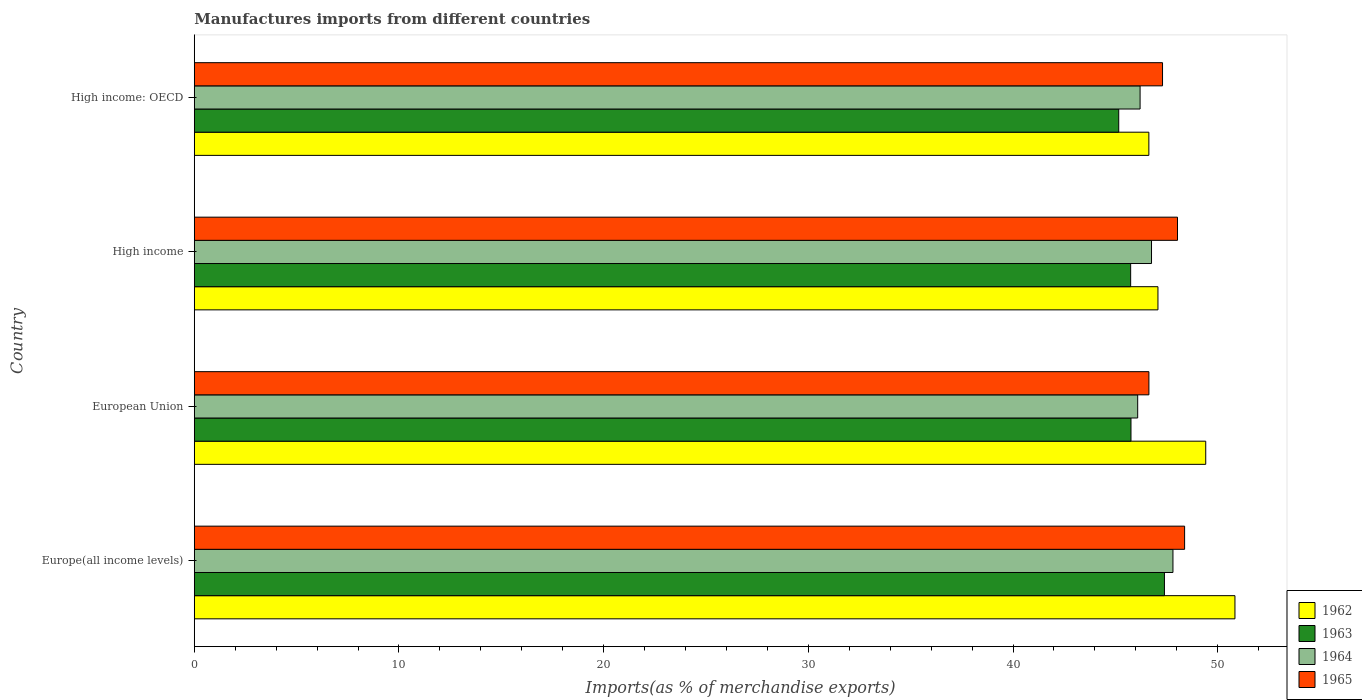How many groups of bars are there?
Keep it short and to the point. 4. Are the number of bars per tick equal to the number of legend labels?
Your answer should be very brief. Yes. How many bars are there on the 1st tick from the top?
Keep it short and to the point. 4. What is the label of the 1st group of bars from the top?
Keep it short and to the point. High income: OECD. What is the percentage of imports to different countries in 1964 in High income: OECD?
Your answer should be compact. 46.21. Across all countries, what is the maximum percentage of imports to different countries in 1964?
Your answer should be compact. 47.81. Across all countries, what is the minimum percentage of imports to different countries in 1965?
Ensure brevity in your answer.  46.64. In which country was the percentage of imports to different countries in 1963 maximum?
Ensure brevity in your answer.  Europe(all income levels). In which country was the percentage of imports to different countries in 1964 minimum?
Offer a very short reply. European Union. What is the total percentage of imports to different countries in 1963 in the graph?
Offer a very short reply. 184.07. What is the difference between the percentage of imports to different countries in 1962 in European Union and that in High income: OECD?
Offer a terse response. 2.78. What is the difference between the percentage of imports to different countries in 1962 in High income: OECD and the percentage of imports to different countries in 1963 in European Union?
Your answer should be very brief. 0.87. What is the average percentage of imports to different countries in 1964 per country?
Offer a very short reply. 46.72. What is the difference between the percentage of imports to different countries in 1964 and percentage of imports to different countries in 1963 in High income: OECD?
Provide a succinct answer. 1.04. What is the ratio of the percentage of imports to different countries in 1962 in Europe(all income levels) to that in European Union?
Your response must be concise. 1.03. Is the percentage of imports to different countries in 1965 in Europe(all income levels) less than that in High income: OECD?
Ensure brevity in your answer.  No. Is the difference between the percentage of imports to different countries in 1964 in Europe(all income levels) and High income: OECD greater than the difference between the percentage of imports to different countries in 1963 in Europe(all income levels) and High income: OECD?
Offer a very short reply. No. What is the difference between the highest and the second highest percentage of imports to different countries in 1964?
Make the answer very short. 1.05. What is the difference between the highest and the lowest percentage of imports to different countries in 1964?
Provide a short and direct response. 1.72. In how many countries, is the percentage of imports to different countries in 1963 greater than the average percentage of imports to different countries in 1963 taken over all countries?
Your answer should be compact. 1. Is it the case that in every country, the sum of the percentage of imports to different countries in 1964 and percentage of imports to different countries in 1962 is greater than the sum of percentage of imports to different countries in 1963 and percentage of imports to different countries in 1965?
Keep it short and to the point. Yes. Is it the case that in every country, the sum of the percentage of imports to different countries in 1962 and percentage of imports to different countries in 1965 is greater than the percentage of imports to different countries in 1963?
Offer a terse response. Yes. Are all the bars in the graph horizontal?
Give a very brief answer. Yes. What is the difference between two consecutive major ticks on the X-axis?
Give a very brief answer. 10. Are the values on the major ticks of X-axis written in scientific E-notation?
Your answer should be very brief. No. Does the graph contain grids?
Give a very brief answer. No. Where does the legend appear in the graph?
Make the answer very short. Bottom right. How many legend labels are there?
Give a very brief answer. 4. What is the title of the graph?
Offer a terse response. Manufactures imports from different countries. Does "1972" appear as one of the legend labels in the graph?
Make the answer very short. No. What is the label or title of the X-axis?
Offer a very short reply. Imports(as % of merchandise exports). What is the label or title of the Y-axis?
Provide a short and direct response. Country. What is the Imports(as % of merchandise exports) of 1962 in Europe(all income levels)?
Ensure brevity in your answer.  50.84. What is the Imports(as % of merchandise exports) in 1963 in Europe(all income levels)?
Provide a short and direct response. 47.4. What is the Imports(as % of merchandise exports) of 1964 in Europe(all income levels)?
Provide a short and direct response. 47.81. What is the Imports(as % of merchandise exports) in 1965 in Europe(all income levels)?
Offer a terse response. 48.38. What is the Imports(as % of merchandise exports) of 1962 in European Union?
Ensure brevity in your answer.  49.41. What is the Imports(as % of merchandise exports) of 1963 in European Union?
Ensure brevity in your answer.  45.76. What is the Imports(as % of merchandise exports) of 1964 in European Union?
Your answer should be compact. 46.09. What is the Imports(as % of merchandise exports) of 1965 in European Union?
Make the answer very short. 46.64. What is the Imports(as % of merchandise exports) of 1962 in High income?
Ensure brevity in your answer.  47.08. What is the Imports(as % of merchandise exports) of 1963 in High income?
Give a very brief answer. 45.75. What is the Imports(as % of merchandise exports) of 1964 in High income?
Ensure brevity in your answer.  46.77. What is the Imports(as % of merchandise exports) in 1965 in High income?
Offer a terse response. 48.04. What is the Imports(as % of merchandise exports) of 1962 in High income: OECD?
Offer a terse response. 46.64. What is the Imports(as % of merchandise exports) of 1963 in High income: OECD?
Ensure brevity in your answer.  45.16. What is the Imports(as % of merchandise exports) in 1964 in High income: OECD?
Your answer should be very brief. 46.21. What is the Imports(as % of merchandise exports) of 1965 in High income: OECD?
Keep it short and to the point. 47.3. Across all countries, what is the maximum Imports(as % of merchandise exports) of 1962?
Give a very brief answer. 50.84. Across all countries, what is the maximum Imports(as % of merchandise exports) of 1963?
Your answer should be compact. 47.4. Across all countries, what is the maximum Imports(as % of merchandise exports) in 1964?
Your response must be concise. 47.81. Across all countries, what is the maximum Imports(as % of merchandise exports) of 1965?
Offer a terse response. 48.38. Across all countries, what is the minimum Imports(as % of merchandise exports) in 1962?
Give a very brief answer. 46.64. Across all countries, what is the minimum Imports(as % of merchandise exports) in 1963?
Offer a terse response. 45.16. Across all countries, what is the minimum Imports(as % of merchandise exports) of 1964?
Your answer should be very brief. 46.09. Across all countries, what is the minimum Imports(as % of merchandise exports) in 1965?
Provide a succinct answer. 46.64. What is the total Imports(as % of merchandise exports) of 1962 in the graph?
Keep it short and to the point. 193.97. What is the total Imports(as % of merchandise exports) in 1963 in the graph?
Provide a succinct answer. 184.07. What is the total Imports(as % of merchandise exports) in 1964 in the graph?
Make the answer very short. 186.88. What is the total Imports(as % of merchandise exports) in 1965 in the graph?
Provide a succinct answer. 190.36. What is the difference between the Imports(as % of merchandise exports) of 1962 in Europe(all income levels) and that in European Union?
Your answer should be very brief. 1.43. What is the difference between the Imports(as % of merchandise exports) in 1963 in Europe(all income levels) and that in European Union?
Your response must be concise. 1.63. What is the difference between the Imports(as % of merchandise exports) in 1964 in Europe(all income levels) and that in European Union?
Your answer should be compact. 1.72. What is the difference between the Imports(as % of merchandise exports) in 1965 in Europe(all income levels) and that in European Union?
Your answer should be compact. 1.74. What is the difference between the Imports(as % of merchandise exports) of 1962 in Europe(all income levels) and that in High income?
Your answer should be very brief. 3.76. What is the difference between the Imports(as % of merchandise exports) of 1963 in Europe(all income levels) and that in High income?
Make the answer very short. 1.65. What is the difference between the Imports(as % of merchandise exports) of 1964 in Europe(all income levels) and that in High income?
Make the answer very short. 1.05. What is the difference between the Imports(as % of merchandise exports) in 1965 in Europe(all income levels) and that in High income?
Give a very brief answer. 0.35. What is the difference between the Imports(as % of merchandise exports) of 1962 in Europe(all income levels) and that in High income: OECD?
Offer a very short reply. 4.21. What is the difference between the Imports(as % of merchandise exports) of 1963 in Europe(all income levels) and that in High income: OECD?
Offer a terse response. 2.23. What is the difference between the Imports(as % of merchandise exports) in 1964 in Europe(all income levels) and that in High income: OECD?
Give a very brief answer. 1.61. What is the difference between the Imports(as % of merchandise exports) in 1965 in Europe(all income levels) and that in High income: OECD?
Provide a short and direct response. 1.08. What is the difference between the Imports(as % of merchandise exports) in 1962 in European Union and that in High income?
Offer a terse response. 2.33. What is the difference between the Imports(as % of merchandise exports) of 1963 in European Union and that in High income?
Your response must be concise. 0.02. What is the difference between the Imports(as % of merchandise exports) of 1964 in European Union and that in High income?
Your answer should be compact. -0.68. What is the difference between the Imports(as % of merchandise exports) of 1965 in European Union and that in High income?
Offer a very short reply. -1.4. What is the difference between the Imports(as % of merchandise exports) in 1962 in European Union and that in High income: OECD?
Your answer should be very brief. 2.78. What is the difference between the Imports(as % of merchandise exports) in 1963 in European Union and that in High income: OECD?
Ensure brevity in your answer.  0.6. What is the difference between the Imports(as % of merchandise exports) in 1964 in European Union and that in High income: OECD?
Offer a terse response. -0.12. What is the difference between the Imports(as % of merchandise exports) of 1965 in European Union and that in High income: OECD?
Provide a short and direct response. -0.67. What is the difference between the Imports(as % of merchandise exports) in 1962 in High income and that in High income: OECD?
Your response must be concise. 0.44. What is the difference between the Imports(as % of merchandise exports) in 1963 in High income and that in High income: OECD?
Give a very brief answer. 0.58. What is the difference between the Imports(as % of merchandise exports) of 1964 in High income and that in High income: OECD?
Provide a succinct answer. 0.56. What is the difference between the Imports(as % of merchandise exports) in 1965 in High income and that in High income: OECD?
Your response must be concise. 0.73. What is the difference between the Imports(as % of merchandise exports) of 1962 in Europe(all income levels) and the Imports(as % of merchandise exports) of 1963 in European Union?
Your response must be concise. 5.08. What is the difference between the Imports(as % of merchandise exports) of 1962 in Europe(all income levels) and the Imports(as % of merchandise exports) of 1964 in European Union?
Your response must be concise. 4.75. What is the difference between the Imports(as % of merchandise exports) in 1962 in Europe(all income levels) and the Imports(as % of merchandise exports) in 1965 in European Union?
Offer a terse response. 4.2. What is the difference between the Imports(as % of merchandise exports) in 1963 in Europe(all income levels) and the Imports(as % of merchandise exports) in 1964 in European Union?
Offer a very short reply. 1.31. What is the difference between the Imports(as % of merchandise exports) in 1963 in Europe(all income levels) and the Imports(as % of merchandise exports) in 1965 in European Union?
Give a very brief answer. 0.76. What is the difference between the Imports(as % of merchandise exports) of 1964 in Europe(all income levels) and the Imports(as % of merchandise exports) of 1965 in European Union?
Ensure brevity in your answer.  1.18. What is the difference between the Imports(as % of merchandise exports) of 1962 in Europe(all income levels) and the Imports(as % of merchandise exports) of 1963 in High income?
Make the answer very short. 5.1. What is the difference between the Imports(as % of merchandise exports) of 1962 in Europe(all income levels) and the Imports(as % of merchandise exports) of 1964 in High income?
Make the answer very short. 4.08. What is the difference between the Imports(as % of merchandise exports) in 1962 in Europe(all income levels) and the Imports(as % of merchandise exports) in 1965 in High income?
Offer a terse response. 2.81. What is the difference between the Imports(as % of merchandise exports) in 1963 in Europe(all income levels) and the Imports(as % of merchandise exports) in 1964 in High income?
Offer a terse response. 0.63. What is the difference between the Imports(as % of merchandise exports) in 1963 in Europe(all income levels) and the Imports(as % of merchandise exports) in 1965 in High income?
Your response must be concise. -0.64. What is the difference between the Imports(as % of merchandise exports) of 1964 in Europe(all income levels) and the Imports(as % of merchandise exports) of 1965 in High income?
Provide a short and direct response. -0.22. What is the difference between the Imports(as % of merchandise exports) of 1962 in Europe(all income levels) and the Imports(as % of merchandise exports) of 1963 in High income: OECD?
Offer a terse response. 5.68. What is the difference between the Imports(as % of merchandise exports) of 1962 in Europe(all income levels) and the Imports(as % of merchandise exports) of 1964 in High income: OECD?
Your answer should be very brief. 4.63. What is the difference between the Imports(as % of merchandise exports) of 1962 in Europe(all income levels) and the Imports(as % of merchandise exports) of 1965 in High income: OECD?
Keep it short and to the point. 3.54. What is the difference between the Imports(as % of merchandise exports) in 1963 in Europe(all income levels) and the Imports(as % of merchandise exports) in 1964 in High income: OECD?
Your answer should be very brief. 1.19. What is the difference between the Imports(as % of merchandise exports) in 1963 in Europe(all income levels) and the Imports(as % of merchandise exports) in 1965 in High income: OECD?
Ensure brevity in your answer.  0.09. What is the difference between the Imports(as % of merchandise exports) of 1964 in Europe(all income levels) and the Imports(as % of merchandise exports) of 1965 in High income: OECD?
Make the answer very short. 0.51. What is the difference between the Imports(as % of merchandise exports) of 1962 in European Union and the Imports(as % of merchandise exports) of 1963 in High income?
Your response must be concise. 3.67. What is the difference between the Imports(as % of merchandise exports) in 1962 in European Union and the Imports(as % of merchandise exports) in 1964 in High income?
Provide a succinct answer. 2.65. What is the difference between the Imports(as % of merchandise exports) of 1962 in European Union and the Imports(as % of merchandise exports) of 1965 in High income?
Keep it short and to the point. 1.38. What is the difference between the Imports(as % of merchandise exports) of 1963 in European Union and the Imports(as % of merchandise exports) of 1964 in High income?
Your answer should be compact. -1. What is the difference between the Imports(as % of merchandise exports) of 1963 in European Union and the Imports(as % of merchandise exports) of 1965 in High income?
Keep it short and to the point. -2.27. What is the difference between the Imports(as % of merchandise exports) in 1964 in European Union and the Imports(as % of merchandise exports) in 1965 in High income?
Give a very brief answer. -1.94. What is the difference between the Imports(as % of merchandise exports) of 1962 in European Union and the Imports(as % of merchandise exports) of 1963 in High income: OECD?
Offer a terse response. 4.25. What is the difference between the Imports(as % of merchandise exports) in 1962 in European Union and the Imports(as % of merchandise exports) in 1964 in High income: OECD?
Your response must be concise. 3.21. What is the difference between the Imports(as % of merchandise exports) of 1962 in European Union and the Imports(as % of merchandise exports) of 1965 in High income: OECD?
Make the answer very short. 2.11. What is the difference between the Imports(as % of merchandise exports) in 1963 in European Union and the Imports(as % of merchandise exports) in 1964 in High income: OECD?
Provide a succinct answer. -0.44. What is the difference between the Imports(as % of merchandise exports) of 1963 in European Union and the Imports(as % of merchandise exports) of 1965 in High income: OECD?
Your answer should be very brief. -1.54. What is the difference between the Imports(as % of merchandise exports) in 1964 in European Union and the Imports(as % of merchandise exports) in 1965 in High income: OECD?
Keep it short and to the point. -1.21. What is the difference between the Imports(as % of merchandise exports) of 1962 in High income and the Imports(as % of merchandise exports) of 1963 in High income: OECD?
Provide a succinct answer. 1.92. What is the difference between the Imports(as % of merchandise exports) of 1962 in High income and the Imports(as % of merchandise exports) of 1964 in High income: OECD?
Your answer should be very brief. 0.87. What is the difference between the Imports(as % of merchandise exports) of 1962 in High income and the Imports(as % of merchandise exports) of 1965 in High income: OECD?
Your answer should be very brief. -0.22. What is the difference between the Imports(as % of merchandise exports) in 1963 in High income and the Imports(as % of merchandise exports) in 1964 in High income: OECD?
Your response must be concise. -0.46. What is the difference between the Imports(as % of merchandise exports) in 1963 in High income and the Imports(as % of merchandise exports) in 1965 in High income: OECD?
Offer a terse response. -1.56. What is the difference between the Imports(as % of merchandise exports) in 1964 in High income and the Imports(as % of merchandise exports) in 1965 in High income: OECD?
Your answer should be compact. -0.54. What is the average Imports(as % of merchandise exports) in 1962 per country?
Your response must be concise. 48.49. What is the average Imports(as % of merchandise exports) of 1963 per country?
Provide a short and direct response. 46.02. What is the average Imports(as % of merchandise exports) of 1964 per country?
Ensure brevity in your answer.  46.72. What is the average Imports(as % of merchandise exports) in 1965 per country?
Make the answer very short. 47.59. What is the difference between the Imports(as % of merchandise exports) of 1962 and Imports(as % of merchandise exports) of 1963 in Europe(all income levels)?
Give a very brief answer. 3.45. What is the difference between the Imports(as % of merchandise exports) of 1962 and Imports(as % of merchandise exports) of 1964 in Europe(all income levels)?
Ensure brevity in your answer.  3.03. What is the difference between the Imports(as % of merchandise exports) in 1962 and Imports(as % of merchandise exports) in 1965 in Europe(all income levels)?
Your answer should be compact. 2.46. What is the difference between the Imports(as % of merchandise exports) in 1963 and Imports(as % of merchandise exports) in 1964 in Europe(all income levels)?
Provide a short and direct response. -0.42. What is the difference between the Imports(as % of merchandise exports) of 1963 and Imports(as % of merchandise exports) of 1965 in Europe(all income levels)?
Your answer should be very brief. -0.99. What is the difference between the Imports(as % of merchandise exports) of 1964 and Imports(as % of merchandise exports) of 1965 in Europe(all income levels)?
Your response must be concise. -0.57. What is the difference between the Imports(as % of merchandise exports) in 1962 and Imports(as % of merchandise exports) in 1963 in European Union?
Your answer should be compact. 3.65. What is the difference between the Imports(as % of merchandise exports) of 1962 and Imports(as % of merchandise exports) of 1964 in European Union?
Offer a terse response. 3.32. What is the difference between the Imports(as % of merchandise exports) in 1962 and Imports(as % of merchandise exports) in 1965 in European Union?
Your answer should be compact. 2.78. What is the difference between the Imports(as % of merchandise exports) in 1963 and Imports(as % of merchandise exports) in 1964 in European Union?
Provide a succinct answer. -0.33. What is the difference between the Imports(as % of merchandise exports) of 1963 and Imports(as % of merchandise exports) of 1965 in European Union?
Your response must be concise. -0.88. What is the difference between the Imports(as % of merchandise exports) of 1964 and Imports(as % of merchandise exports) of 1965 in European Union?
Provide a succinct answer. -0.55. What is the difference between the Imports(as % of merchandise exports) of 1962 and Imports(as % of merchandise exports) of 1963 in High income?
Give a very brief answer. 1.33. What is the difference between the Imports(as % of merchandise exports) of 1962 and Imports(as % of merchandise exports) of 1964 in High income?
Your answer should be compact. 0.31. What is the difference between the Imports(as % of merchandise exports) in 1962 and Imports(as % of merchandise exports) in 1965 in High income?
Ensure brevity in your answer.  -0.96. What is the difference between the Imports(as % of merchandise exports) in 1963 and Imports(as % of merchandise exports) in 1964 in High income?
Provide a short and direct response. -1.02. What is the difference between the Imports(as % of merchandise exports) of 1963 and Imports(as % of merchandise exports) of 1965 in High income?
Your answer should be compact. -2.29. What is the difference between the Imports(as % of merchandise exports) in 1964 and Imports(as % of merchandise exports) in 1965 in High income?
Ensure brevity in your answer.  -1.27. What is the difference between the Imports(as % of merchandise exports) in 1962 and Imports(as % of merchandise exports) in 1963 in High income: OECD?
Your answer should be very brief. 1.47. What is the difference between the Imports(as % of merchandise exports) in 1962 and Imports(as % of merchandise exports) in 1964 in High income: OECD?
Your response must be concise. 0.43. What is the difference between the Imports(as % of merchandise exports) in 1962 and Imports(as % of merchandise exports) in 1965 in High income: OECD?
Your response must be concise. -0.67. What is the difference between the Imports(as % of merchandise exports) of 1963 and Imports(as % of merchandise exports) of 1964 in High income: OECD?
Offer a terse response. -1.04. What is the difference between the Imports(as % of merchandise exports) of 1963 and Imports(as % of merchandise exports) of 1965 in High income: OECD?
Offer a very short reply. -2.14. What is the difference between the Imports(as % of merchandise exports) of 1964 and Imports(as % of merchandise exports) of 1965 in High income: OECD?
Keep it short and to the point. -1.1. What is the ratio of the Imports(as % of merchandise exports) in 1962 in Europe(all income levels) to that in European Union?
Give a very brief answer. 1.03. What is the ratio of the Imports(as % of merchandise exports) in 1963 in Europe(all income levels) to that in European Union?
Your answer should be compact. 1.04. What is the ratio of the Imports(as % of merchandise exports) in 1964 in Europe(all income levels) to that in European Union?
Make the answer very short. 1.04. What is the ratio of the Imports(as % of merchandise exports) of 1965 in Europe(all income levels) to that in European Union?
Ensure brevity in your answer.  1.04. What is the ratio of the Imports(as % of merchandise exports) of 1962 in Europe(all income levels) to that in High income?
Provide a short and direct response. 1.08. What is the ratio of the Imports(as % of merchandise exports) of 1963 in Europe(all income levels) to that in High income?
Ensure brevity in your answer.  1.04. What is the ratio of the Imports(as % of merchandise exports) in 1964 in Europe(all income levels) to that in High income?
Provide a succinct answer. 1.02. What is the ratio of the Imports(as % of merchandise exports) in 1962 in Europe(all income levels) to that in High income: OECD?
Make the answer very short. 1.09. What is the ratio of the Imports(as % of merchandise exports) in 1963 in Europe(all income levels) to that in High income: OECD?
Give a very brief answer. 1.05. What is the ratio of the Imports(as % of merchandise exports) in 1964 in Europe(all income levels) to that in High income: OECD?
Your response must be concise. 1.03. What is the ratio of the Imports(as % of merchandise exports) of 1965 in Europe(all income levels) to that in High income: OECD?
Keep it short and to the point. 1.02. What is the ratio of the Imports(as % of merchandise exports) in 1962 in European Union to that in High income?
Your answer should be very brief. 1.05. What is the ratio of the Imports(as % of merchandise exports) of 1963 in European Union to that in High income?
Your response must be concise. 1. What is the ratio of the Imports(as % of merchandise exports) in 1964 in European Union to that in High income?
Your answer should be compact. 0.99. What is the ratio of the Imports(as % of merchandise exports) in 1965 in European Union to that in High income?
Your answer should be very brief. 0.97. What is the ratio of the Imports(as % of merchandise exports) in 1962 in European Union to that in High income: OECD?
Offer a terse response. 1.06. What is the ratio of the Imports(as % of merchandise exports) of 1963 in European Union to that in High income: OECD?
Your response must be concise. 1.01. What is the ratio of the Imports(as % of merchandise exports) in 1965 in European Union to that in High income: OECD?
Offer a very short reply. 0.99. What is the ratio of the Imports(as % of merchandise exports) in 1962 in High income to that in High income: OECD?
Your answer should be very brief. 1.01. What is the ratio of the Imports(as % of merchandise exports) in 1963 in High income to that in High income: OECD?
Keep it short and to the point. 1.01. What is the ratio of the Imports(as % of merchandise exports) in 1964 in High income to that in High income: OECD?
Your response must be concise. 1.01. What is the ratio of the Imports(as % of merchandise exports) of 1965 in High income to that in High income: OECD?
Give a very brief answer. 1.02. What is the difference between the highest and the second highest Imports(as % of merchandise exports) of 1962?
Provide a succinct answer. 1.43. What is the difference between the highest and the second highest Imports(as % of merchandise exports) of 1963?
Your answer should be compact. 1.63. What is the difference between the highest and the second highest Imports(as % of merchandise exports) in 1964?
Offer a very short reply. 1.05. What is the difference between the highest and the second highest Imports(as % of merchandise exports) of 1965?
Your answer should be very brief. 0.35. What is the difference between the highest and the lowest Imports(as % of merchandise exports) in 1962?
Make the answer very short. 4.21. What is the difference between the highest and the lowest Imports(as % of merchandise exports) of 1963?
Your answer should be very brief. 2.23. What is the difference between the highest and the lowest Imports(as % of merchandise exports) in 1964?
Provide a short and direct response. 1.72. What is the difference between the highest and the lowest Imports(as % of merchandise exports) of 1965?
Offer a very short reply. 1.74. 